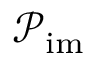<formula> <loc_0><loc_0><loc_500><loc_500>\mathcal { P } _ { i m }</formula> 